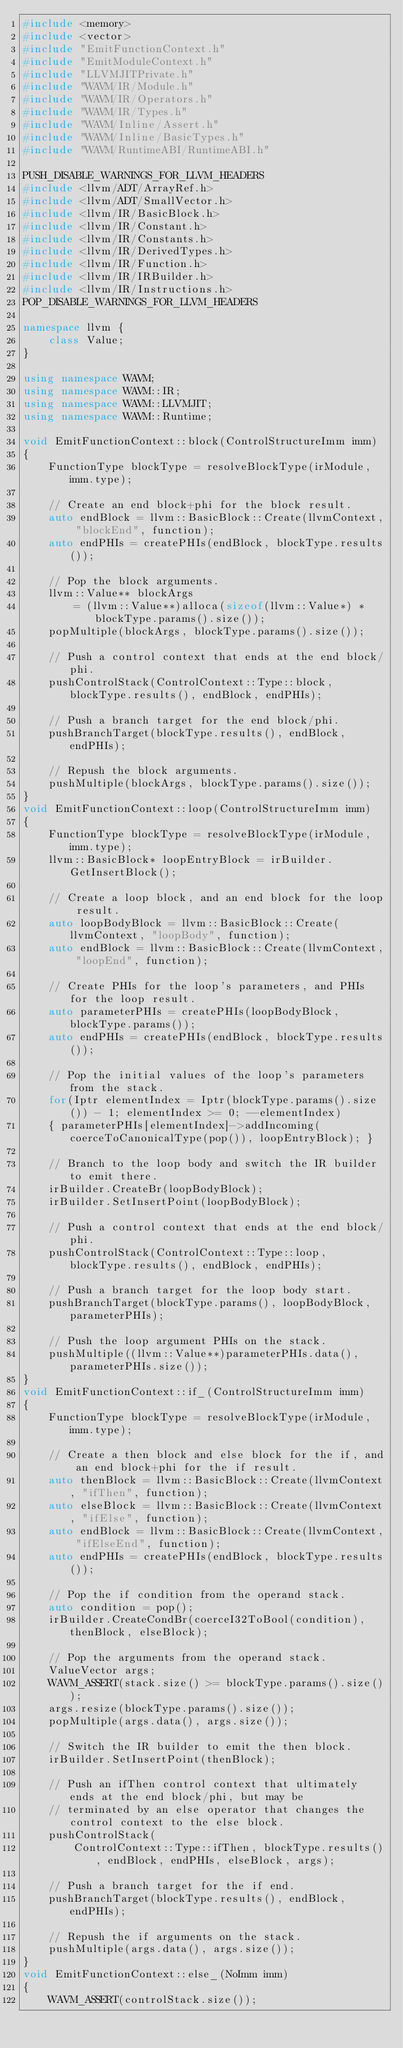<code> <loc_0><loc_0><loc_500><loc_500><_C++_>#include <memory>
#include <vector>
#include "EmitFunctionContext.h"
#include "EmitModuleContext.h"
#include "LLVMJITPrivate.h"
#include "WAVM/IR/Module.h"
#include "WAVM/IR/Operators.h"
#include "WAVM/IR/Types.h"
#include "WAVM/Inline/Assert.h"
#include "WAVM/Inline/BasicTypes.h"
#include "WAVM/RuntimeABI/RuntimeABI.h"

PUSH_DISABLE_WARNINGS_FOR_LLVM_HEADERS
#include <llvm/ADT/ArrayRef.h>
#include <llvm/ADT/SmallVector.h>
#include <llvm/IR/BasicBlock.h>
#include <llvm/IR/Constant.h>
#include <llvm/IR/Constants.h>
#include <llvm/IR/DerivedTypes.h>
#include <llvm/IR/Function.h>
#include <llvm/IR/IRBuilder.h>
#include <llvm/IR/Instructions.h>
POP_DISABLE_WARNINGS_FOR_LLVM_HEADERS

namespace llvm {
	class Value;
}

using namespace WAVM;
using namespace WAVM::IR;
using namespace WAVM::LLVMJIT;
using namespace WAVM::Runtime;

void EmitFunctionContext::block(ControlStructureImm imm)
{
	FunctionType blockType = resolveBlockType(irModule, imm.type);

	// Create an end block+phi for the block result.
	auto endBlock = llvm::BasicBlock::Create(llvmContext, "blockEnd", function);
	auto endPHIs = createPHIs(endBlock, blockType.results());

	// Pop the block arguments.
	llvm::Value** blockArgs
		= (llvm::Value**)alloca(sizeof(llvm::Value*) * blockType.params().size());
	popMultiple(blockArgs, blockType.params().size());

	// Push a control context that ends at the end block/phi.
	pushControlStack(ControlContext::Type::block, blockType.results(), endBlock, endPHIs);

	// Push a branch target for the end block/phi.
	pushBranchTarget(blockType.results(), endBlock, endPHIs);

	// Repush the block arguments.
	pushMultiple(blockArgs, blockType.params().size());
}
void EmitFunctionContext::loop(ControlStructureImm imm)
{
	FunctionType blockType = resolveBlockType(irModule, imm.type);
	llvm::BasicBlock* loopEntryBlock = irBuilder.GetInsertBlock();

	// Create a loop block, and an end block for the loop result.
	auto loopBodyBlock = llvm::BasicBlock::Create(llvmContext, "loopBody", function);
	auto endBlock = llvm::BasicBlock::Create(llvmContext, "loopEnd", function);

	// Create PHIs for the loop's parameters, and PHIs for the loop result.
	auto parameterPHIs = createPHIs(loopBodyBlock, blockType.params());
	auto endPHIs = createPHIs(endBlock, blockType.results());

	// Pop the initial values of the loop's parameters from the stack.
	for(Iptr elementIndex = Iptr(blockType.params().size()) - 1; elementIndex >= 0; --elementIndex)
	{ parameterPHIs[elementIndex]->addIncoming(coerceToCanonicalType(pop()), loopEntryBlock); }

	// Branch to the loop body and switch the IR builder to emit there.
	irBuilder.CreateBr(loopBodyBlock);
	irBuilder.SetInsertPoint(loopBodyBlock);

	// Push a control context that ends at the end block/phi.
	pushControlStack(ControlContext::Type::loop, blockType.results(), endBlock, endPHIs);

	// Push a branch target for the loop body start.
	pushBranchTarget(blockType.params(), loopBodyBlock, parameterPHIs);

	// Push the loop argument PHIs on the stack.
	pushMultiple((llvm::Value**)parameterPHIs.data(), parameterPHIs.size());
}
void EmitFunctionContext::if_(ControlStructureImm imm)
{
	FunctionType blockType = resolveBlockType(irModule, imm.type);

	// Create a then block and else block for the if, and an end block+phi for the if result.
	auto thenBlock = llvm::BasicBlock::Create(llvmContext, "ifThen", function);
	auto elseBlock = llvm::BasicBlock::Create(llvmContext, "ifElse", function);
	auto endBlock = llvm::BasicBlock::Create(llvmContext, "ifElseEnd", function);
	auto endPHIs = createPHIs(endBlock, blockType.results());

	// Pop the if condition from the operand stack.
	auto condition = pop();
	irBuilder.CreateCondBr(coerceI32ToBool(condition), thenBlock, elseBlock);

	// Pop the arguments from the operand stack.
	ValueVector args;
	WAVM_ASSERT(stack.size() >= blockType.params().size());
	args.resize(blockType.params().size());
	popMultiple(args.data(), args.size());

	// Switch the IR builder to emit the then block.
	irBuilder.SetInsertPoint(thenBlock);

	// Push an ifThen control context that ultimately ends at the end block/phi, but may be
	// terminated by an else operator that changes the control context to the else block.
	pushControlStack(
		ControlContext::Type::ifThen, blockType.results(), endBlock, endPHIs, elseBlock, args);

	// Push a branch target for the if end.
	pushBranchTarget(blockType.results(), endBlock, endPHIs);

	// Repush the if arguments on the stack.
	pushMultiple(args.data(), args.size());
}
void EmitFunctionContext::else_(NoImm imm)
{
	WAVM_ASSERT(controlStack.size());</code> 